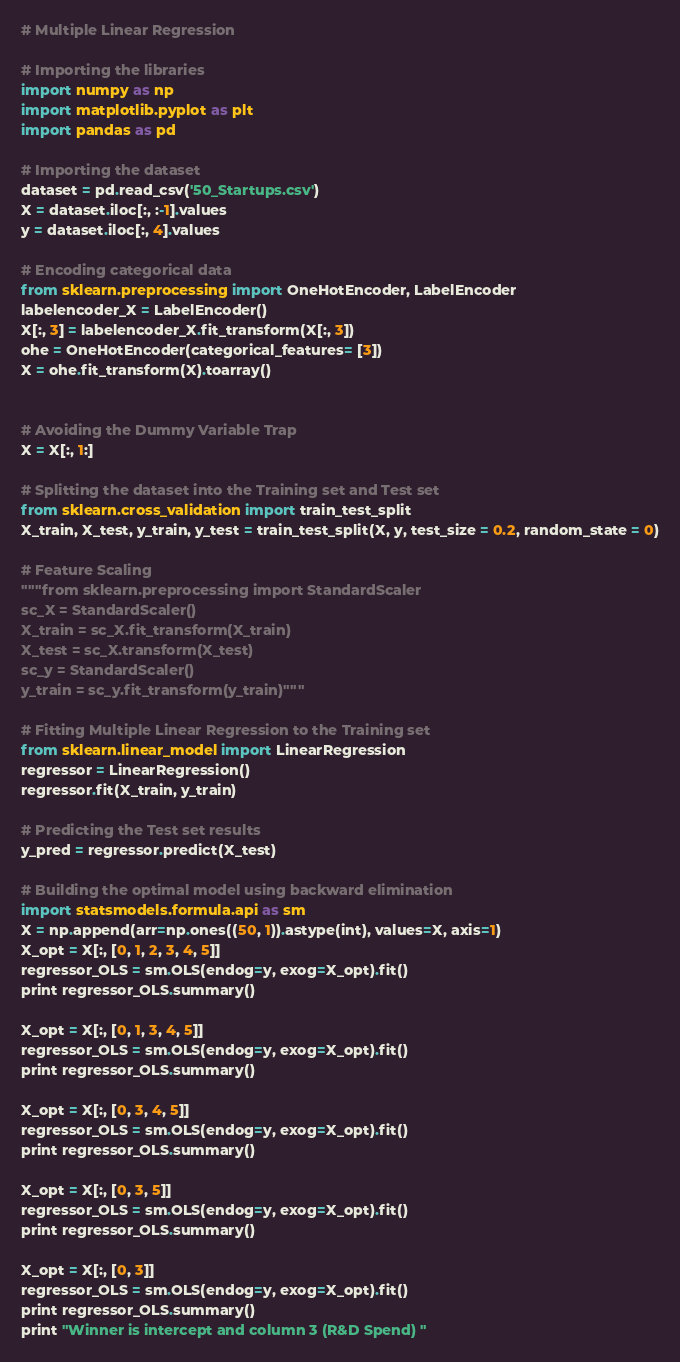<code> <loc_0><loc_0><loc_500><loc_500><_Python_># Multiple Linear Regression

# Importing the libraries
import numpy as np
import matplotlib.pyplot as plt
import pandas as pd

# Importing the dataset
dataset = pd.read_csv('50_Startups.csv')
X = dataset.iloc[:, :-1].values
y = dataset.iloc[:, 4].values

# Encoding categorical data
from sklearn.preprocessing import OneHotEncoder, LabelEncoder
labelencoder_X = LabelEncoder()
X[:, 3] = labelencoder_X.fit_transform(X[:, 3])
ohe = OneHotEncoder(categorical_features= [3])
X = ohe.fit_transform(X).toarray()


# Avoiding the Dummy Variable Trap
X = X[:, 1:]

# Splitting the dataset into the Training set and Test set
from sklearn.cross_validation import train_test_split
X_train, X_test, y_train, y_test = train_test_split(X, y, test_size = 0.2, random_state = 0)

# Feature Scaling
"""from sklearn.preprocessing import StandardScaler
sc_X = StandardScaler()
X_train = sc_X.fit_transform(X_train)
X_test = sc_X.transform(X_test)
sc_y = StandardScaler()
y_train = sc_y.fit_transform(y_train)"""

# Fitting Multiple Linear Regression to the Training set
from sklearn.linear_model import LinearRegression
regressor = LinearRegression()
regressor.fit(X_train, y_train)

# Predicting the Test set results
y_pred = regressor.predict(X_test)

# Building the optimal model using backward elimination
import statsmodels.formula.api as sm
X = np.append(arr=np.ones((50, 1)).astype(int), values=X, axis=1)
X_opt = X[:, [0, 1, 2, 3, 4, 5]]
regressor_OLS = sm.OLS(endog=y, exog=X_opt).fit()
print regressor_OLS.summary()

X_opt = X[:, [0, 1, 3, 4, 5]]
regressor_OLS = sm.OLS(endog=y, exog=X_opt).fit()
print regressor_OLS.summary()

X_opt = X[:, [0, 3, 4, 5]]
regressor_OLS = sm.OLS(endog=y, exog=X_opt).fit()
print regressor_OLS.summary()

X_opt = X[:, [0, 3, 5]]
regressor_OLS = sm.OLS(endog=y, exog=X_opt).fit()
print regressor_OLS.summary()

X_opt = X[:, [0, 3]]
regressor_OLS = sm.OLS(endog=y, exog=X_opt).fit()
print regressor_OLS.summary()
print "Winner is intercept and column 3 (R&D Spend) "</code> 